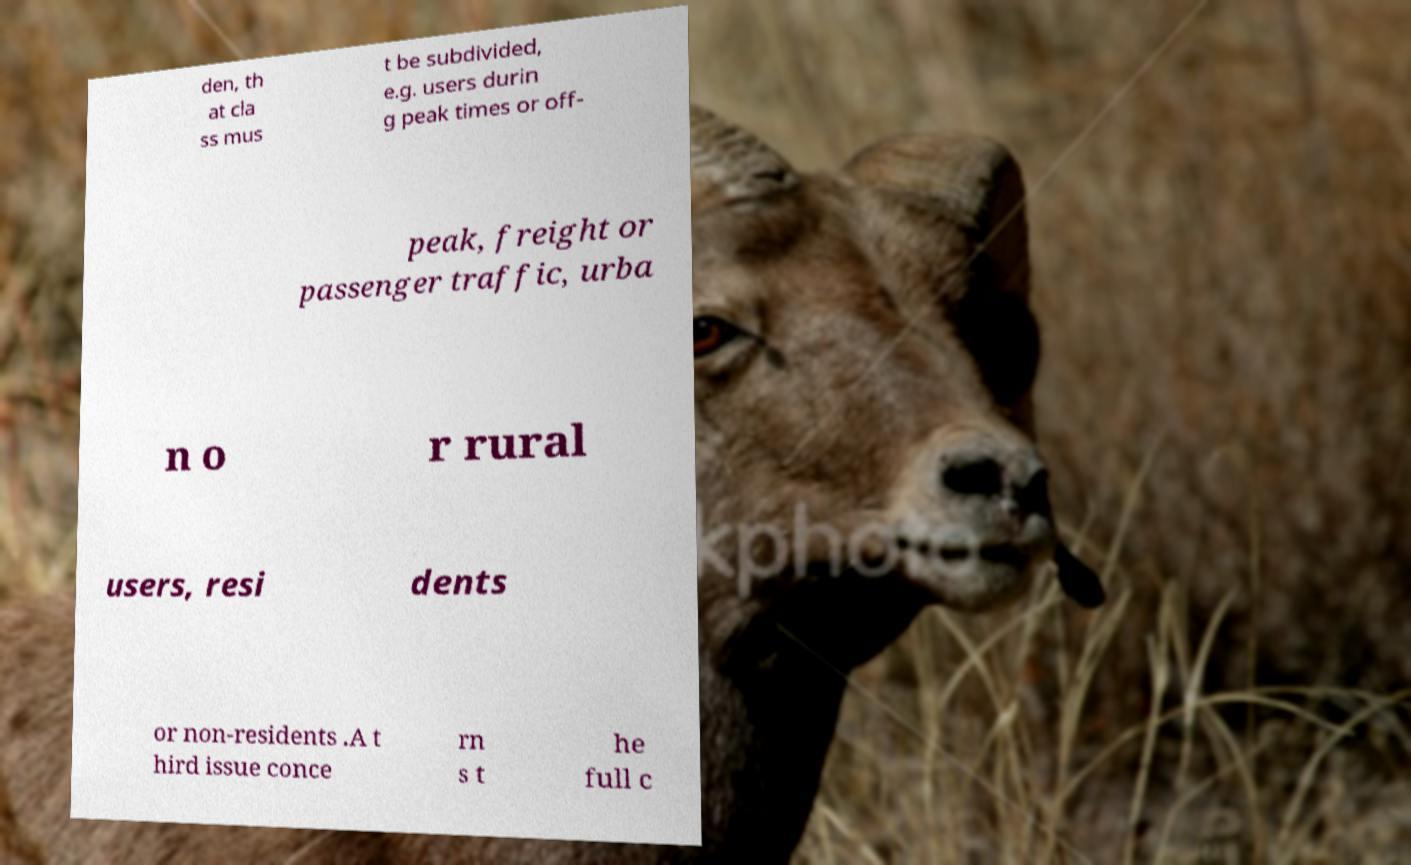For documentation purposes, I need the text within this image transcribed. Could you provide that? den, th at cla ss mus t be subdivided, e.g. users durin g peak times or off- peak, freight or passenger traffic, urba n o r rural users, resi dents or non-residents .A t hird issue conce rn s t he full c 